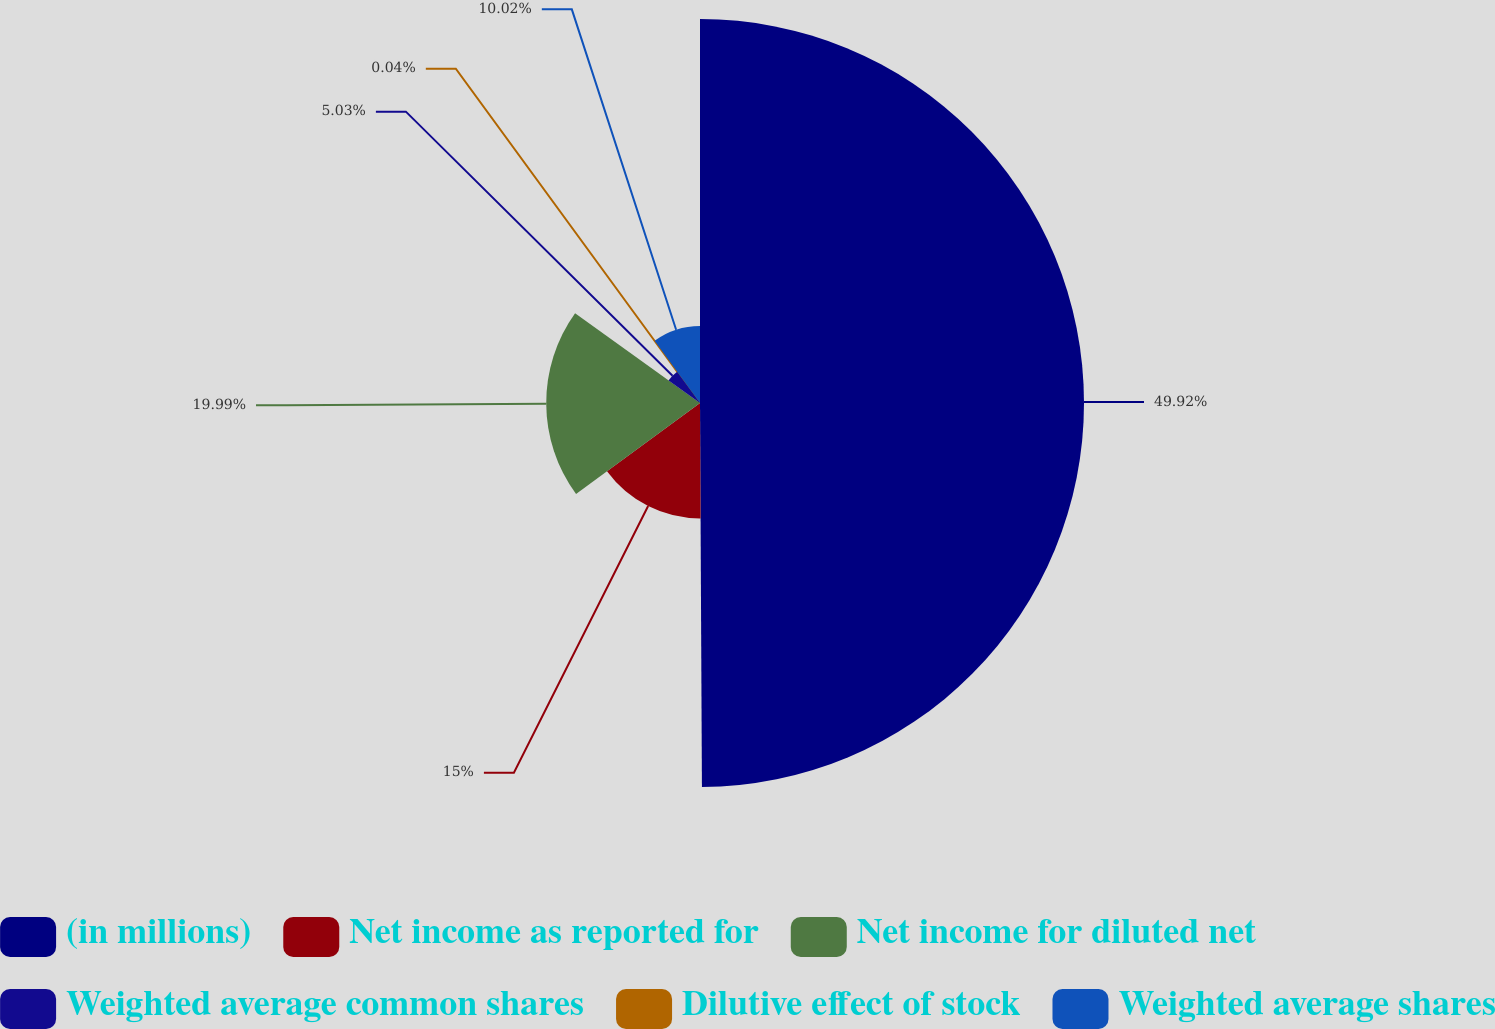<chart> <loc_0><loc_0><loc_500><loc_500><pie_chart><fcel>(in millions)<fcel>Net income as reported for<fcel>Net income for diluted net<fcel>Weighted average common shares<fcel>Dilutive effect of stock<fcel>Weighted average shares<nl><fcel>49.92%<fcel>15.0%<fcel>19.99%<fcel>5.03%<fcel>0.04%<fcel>10.02%<nl></chart> 